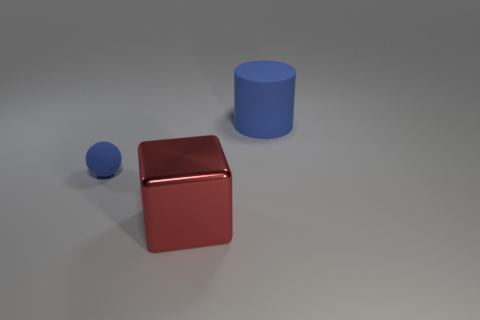Add 3 big cylinders. How many objects exist? 6 Subtract all cylinders. How many objects are left? 2 Add 2 tiny blue rubber things. How many tiny blue rubber things exist? 3 Subtract 0 purple cylinders. How many objects are left? 3 Subtract all big cyan matte blocks. Subtract all blue balls. How many objects are left? 2 Add 1 metallic objects. How many metallic objects are left? 2 